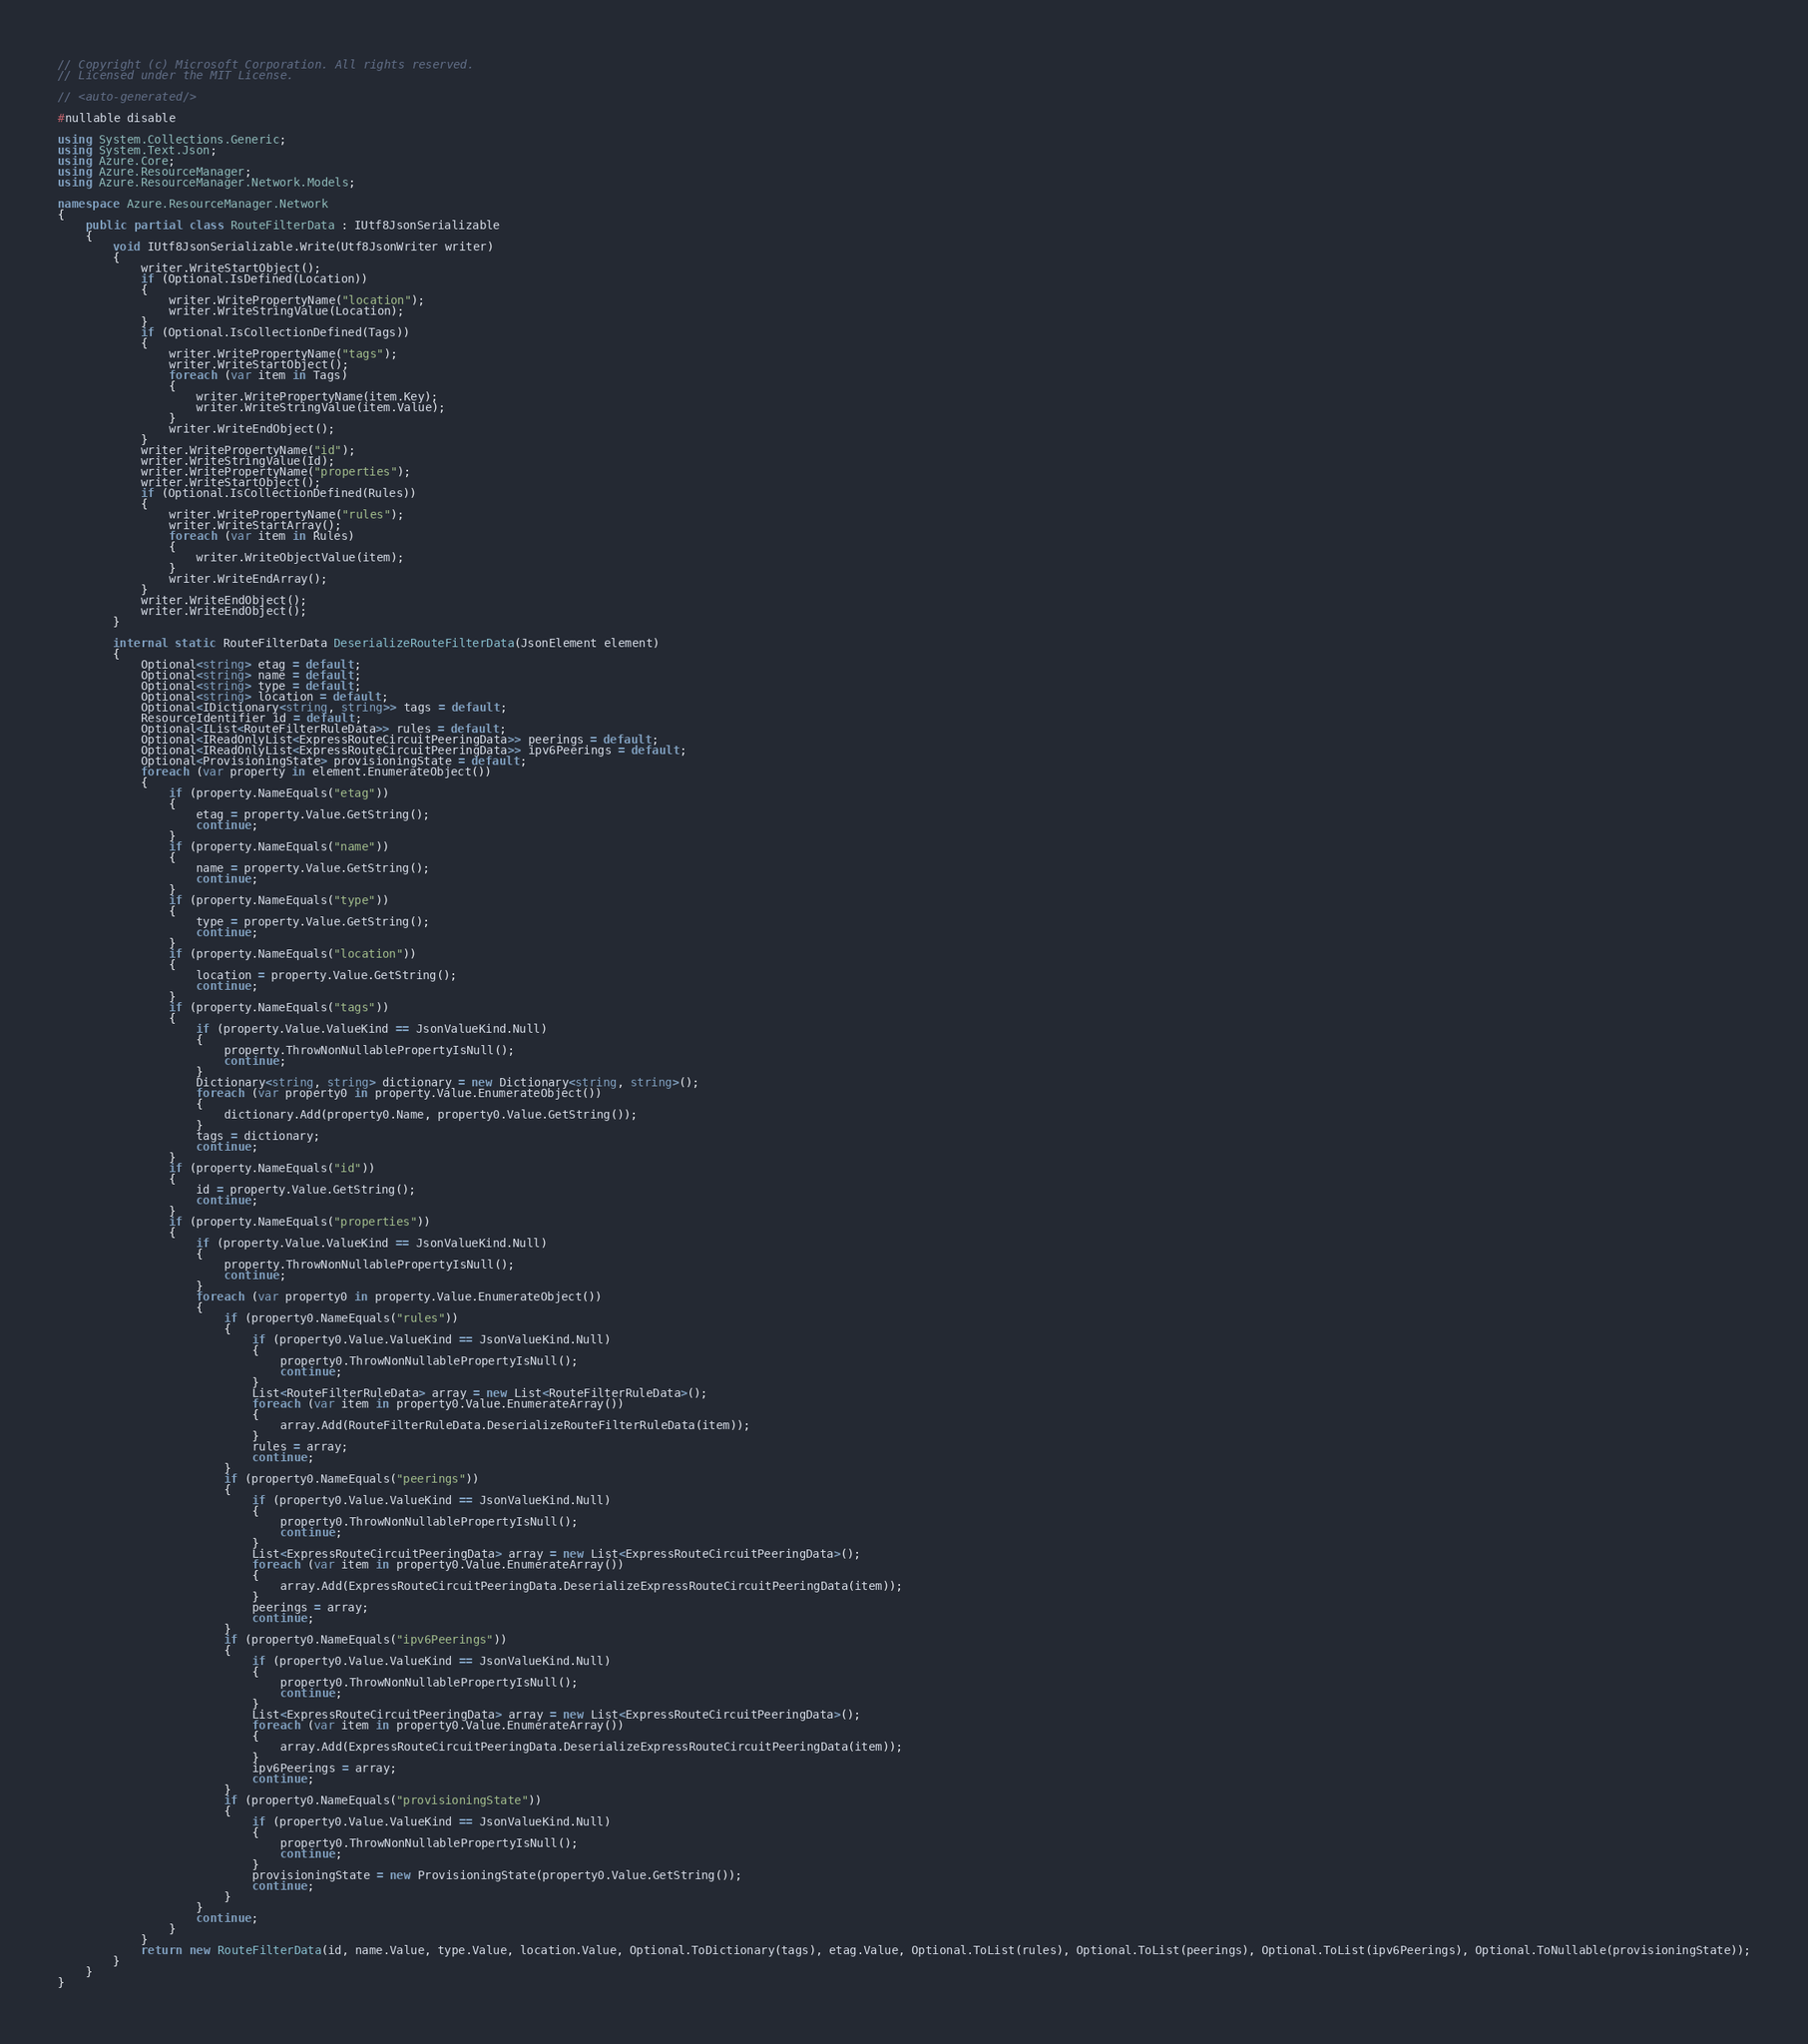Convert code to text. <code><loc_0><loc_0><loc_500><loc_500><_C#_>// Copyright (c) Microsoft Corporation. All rights reserved.
// Licensed under the MIT License.

// <auto-generated/>

#nullable disable

using System.Collections.Generic;
using System.Text.Json;
using Azure.Core;
using Azure.ResourceManager;
using Azure.ResourceManager.Network.Models;

namespace Azure.ResourceManager.Network
{
    public partial class RouteFilterData : IUtf8JsonSerializable
    {
        void IUtf8JsonSerializable.Write(Utf8JsonWriter writer)
        {
            writer.WriteStartObject();
            if (Optional.IsDefined(Location))
            {
                writer.WritePropertyName("location");
                writer.WriteStringValue(Location);
            }
            if (Optional.IsCollectionDefined(Tags))
            {
                writer.WritePropertyName("tags");
                writer.WriteStartObject();
                foreach (var item in Tags)
                {
                    writer.WritePropertyName(item.Key);
                    writer.WriteStringValue(item.Value);
                }
                writer.WriteEndObject();
            }
            writer.WritePropertyName("id");
            writer.WriteStringValue(Id);
            writer.WritePropertyName("properties");
            writer.WriteStartObject();
            if (Optional.IsCollectionDefined(Rules))
            {
                writer.WritePropertyName("rules");
                writer.WriteStartArray();
                foreach (var item in Rules)
                {
                    writer.WriteObjectValue(item);
                }
                writer.WriteEndArray();
            }
            writer.WriteEndObject();
            writer.WriteEndObject();
        }

        internal static RouteFilterData DeserializeRouteFilterData(JsonElement element)
        {
            Optional<string> etag = default;
            Optional<string> name = default;
            Optional<string> type = default;
            Optional<string> location = default;
            Optional<IDictionary<string, string>> tags = default;
            ResourceIdentifier id = default;
            Optional<IList<RouteFilterRuleData>> rules = default;
            Optional<IReadOnlyList<ExpressRouteCircuitPeeringData>> peerings = default;
            Optional<IReadOnlyList<ExpressRouteCircuitPeeringData>> ipv6Peerings = default;
            Optional<ProvisioningState> provisioningState = default;
            foreach (var property in element.EnumerateObject())
            {
                if (property.NameEquals("etag"))
                {
                    etag = property.Value.GetString();
                    continue;
                }
                if (property.NameEquals("name"))
                {
                    name = property.Value.GetString();
                    continue;
                }
                if (property.NameEquals("type"))
                {
                    type = property.Value.GetString();
                    continue;
                }
                if (property.NameEquals("location"))
                {
                    location = property.Value.GetString();
                    continue;
                }
                if (property.NameEquals("tags"))
                {
                    if (property.Value.ValueKind == JsonValueKind.Null)
                    {
                        property.ThrowNonNullablePropertyIsNull();
                        continue;
                    }
                    Dictionary<string, string> dictionary = new Dictionary<string, string>();
                    foreach (var property0 in property.Value.EnumerateObject())
                    {
                        dictionary.Add(property0.Name, property0.Value.GetString());
                    }
                    tags = dictionary;
                    continue;
                }
                if (property.NameEquals("id"))
                {
                    id = property.Value.GetString();
                    continue;
                }
                if (property.NameEquals("properties"))
                {
                    if (property.Value.ValueKind == JsonValueKind.Null)
                    {
                        property.ThrowNonNullablePropertyIsNull();
                        continue;
                    }
                    foreach (var property0 in property.Value.EnumerateObject())
                    {
                        if (property0.NameEquals("rules"))
                        {
                            if (property0.Value.ValueKind == JsonValueKind.Null)
                            {
                                property0.ThrowNonNullablePropertyIsNull();
                                continue;
                            }
                            List<RouteFilterRuleData> array = new List<RouteFilterRuleData>();
                            foreach (var item in property0.Value.EnumerateArray())
                            {
                                array.Add(RouteFilterRuleData.DeserializeRouteFilterRuleData(item));
                            }
                            rules = array;
                            continue;
                        }
                        if (property0.NameEquals("peerings"))
                        {
                            if (property0.Value.ValueKind == JsonValueKind.Null)
                            {
                                property0.ThrowNonNullablePropertyIsNull();
                                continue;
                            }
                            List<ExpressRouteCircuitPeeringData> array = new List<ExpressRouteCircuitPeeringData>();
                            foreach (var item in property0.Value.EnumerateArray())
                            {
                                array.Add(ExpressRouteCircuitPeeringData.DeserializeExpressRouteCircuitPeeringData(item));
                            }
                            peerings = array;
                            continue;
                        }
                        if (property0.NameEquals("ipv6Peerings"))
                        {
                            if (property0.Value.ValueKind == JsonValueKind.Null)
                            {
                                property0.ThrowNonNullablePropertyIsNull();
                                continue;
                            }
                            List<ExpressRouteCircuitPeeringData> array = new List<ExpressRouteCircuitPeeringData>();
                            foreach (var item in property0.Value.EnumerateArray())
                            {
                                array.Add(ExpressRouteCircuitPeeringData.DeserializeExpressRouteCircuitPeeringData(item));
                            }
                            ipv6Peerings = array;
                            continue;
                        }
                        if (property0.NameEquals("provisioningState"))
                        {
                            if (property0.Value.ValueKind == JsonValueKind.Null)
                            {
                                property0.ThrowNonNullablePropertyIsNull();
                                continue;
                            }
                            provisioningState = new ProvisioningState(property0.Value.GetString());
                            continue;
                        }
                    }
                    continue;
                }
            }
            return new RouteFilterData(id, name.Value, type.Value, location.Value, Optional.ToDictionary(tags), etag.Value, Optional.ToList(rules), Optional.ToList(peerings), Optional.ToList(ipv6Peerings), Optional.ToNullable(provisioningState));
        }
    }
}
</code> 